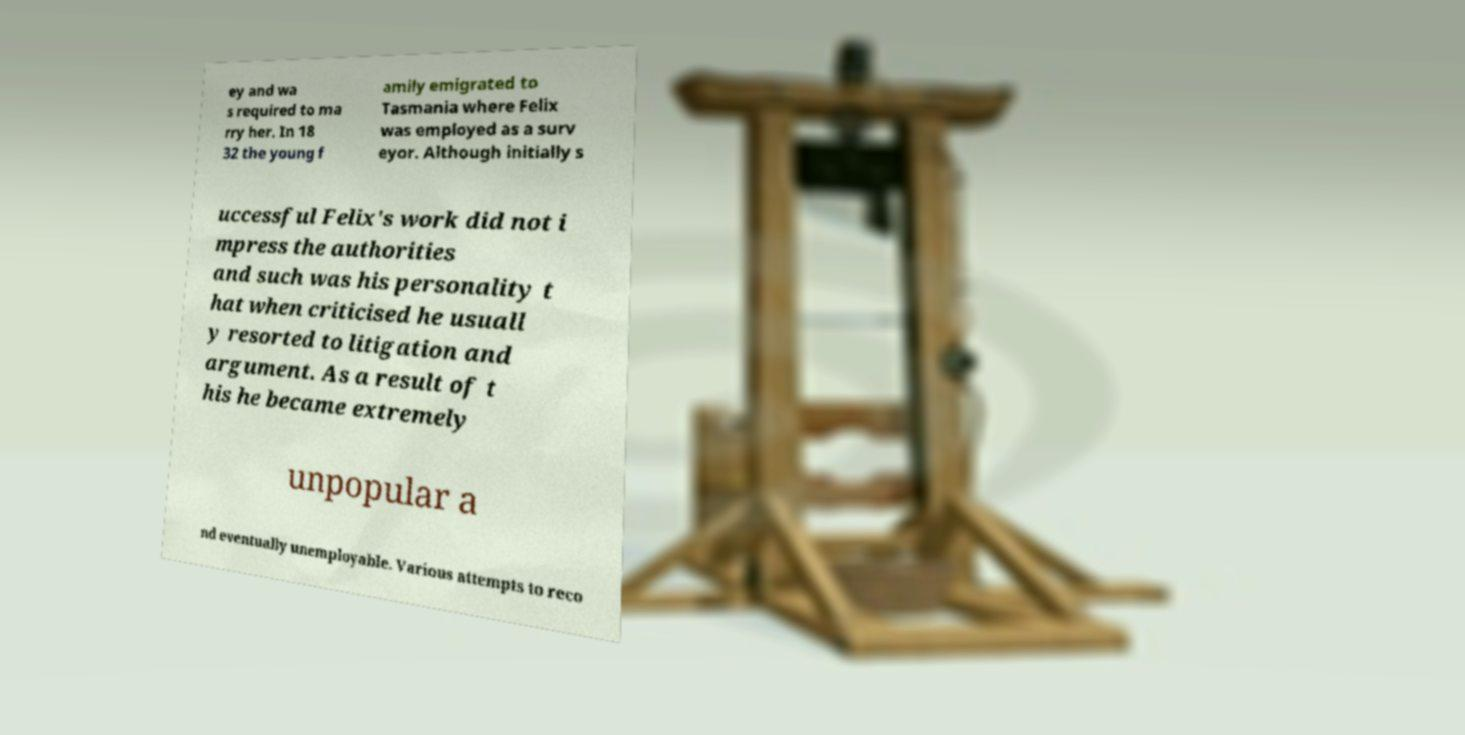What messages or text are displayed in this image? I need them in a readable, typed format. ey and wa s required to ma rry her. In 18 32 the young f amily emigrated to Tasmania where Felix was employed as a surv eyor. Although initially s uccessful Felix's work did not i mpress the authorities and such was his personality t hat when criticised he usuall y resorted to litigation and argument. As a result of t his he became extremely unpopular a nd eventually unemployable. Various attempts to reco 